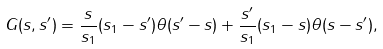Convert formula to latex. <formula><loc_0><loc_0><loc_500><loc_500>G ( s , s ^ { \prime } ) = \frac { s } { s _ { 1 } } ( s _ { 1 } - s ^ { \prime } ) \theta ( s ^ { \prime } - s ) + \frac { s ^ { \prime } } { s _ { 1 } } ( s _ { 1 } - s ) \theta ( s - s ^ { \prime } ) ,</formula> 